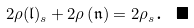<formula> <loc_0><loc_0><loc_500><loc_500>2 \rho ( \mathfrak { l } ) _ { s } + 2 \rho \left ( \mathfrak { n } \right ) = 2 \rho _ { s } \text {. } \blacksquare</formula> 